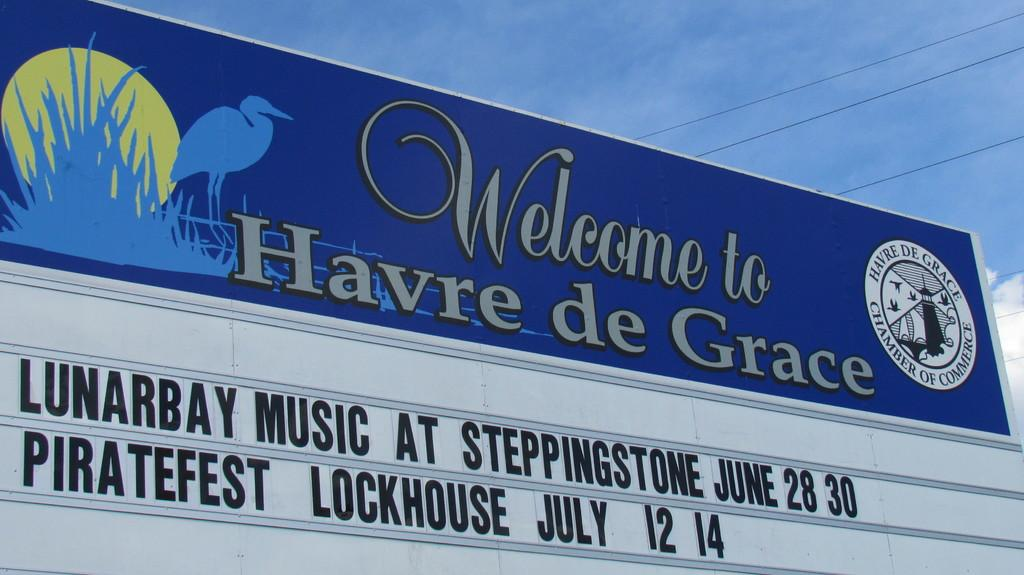<image>
Relay a brief, clear account of the picture shown. A church sign advertises for Piratefest Lockhouse in July. 